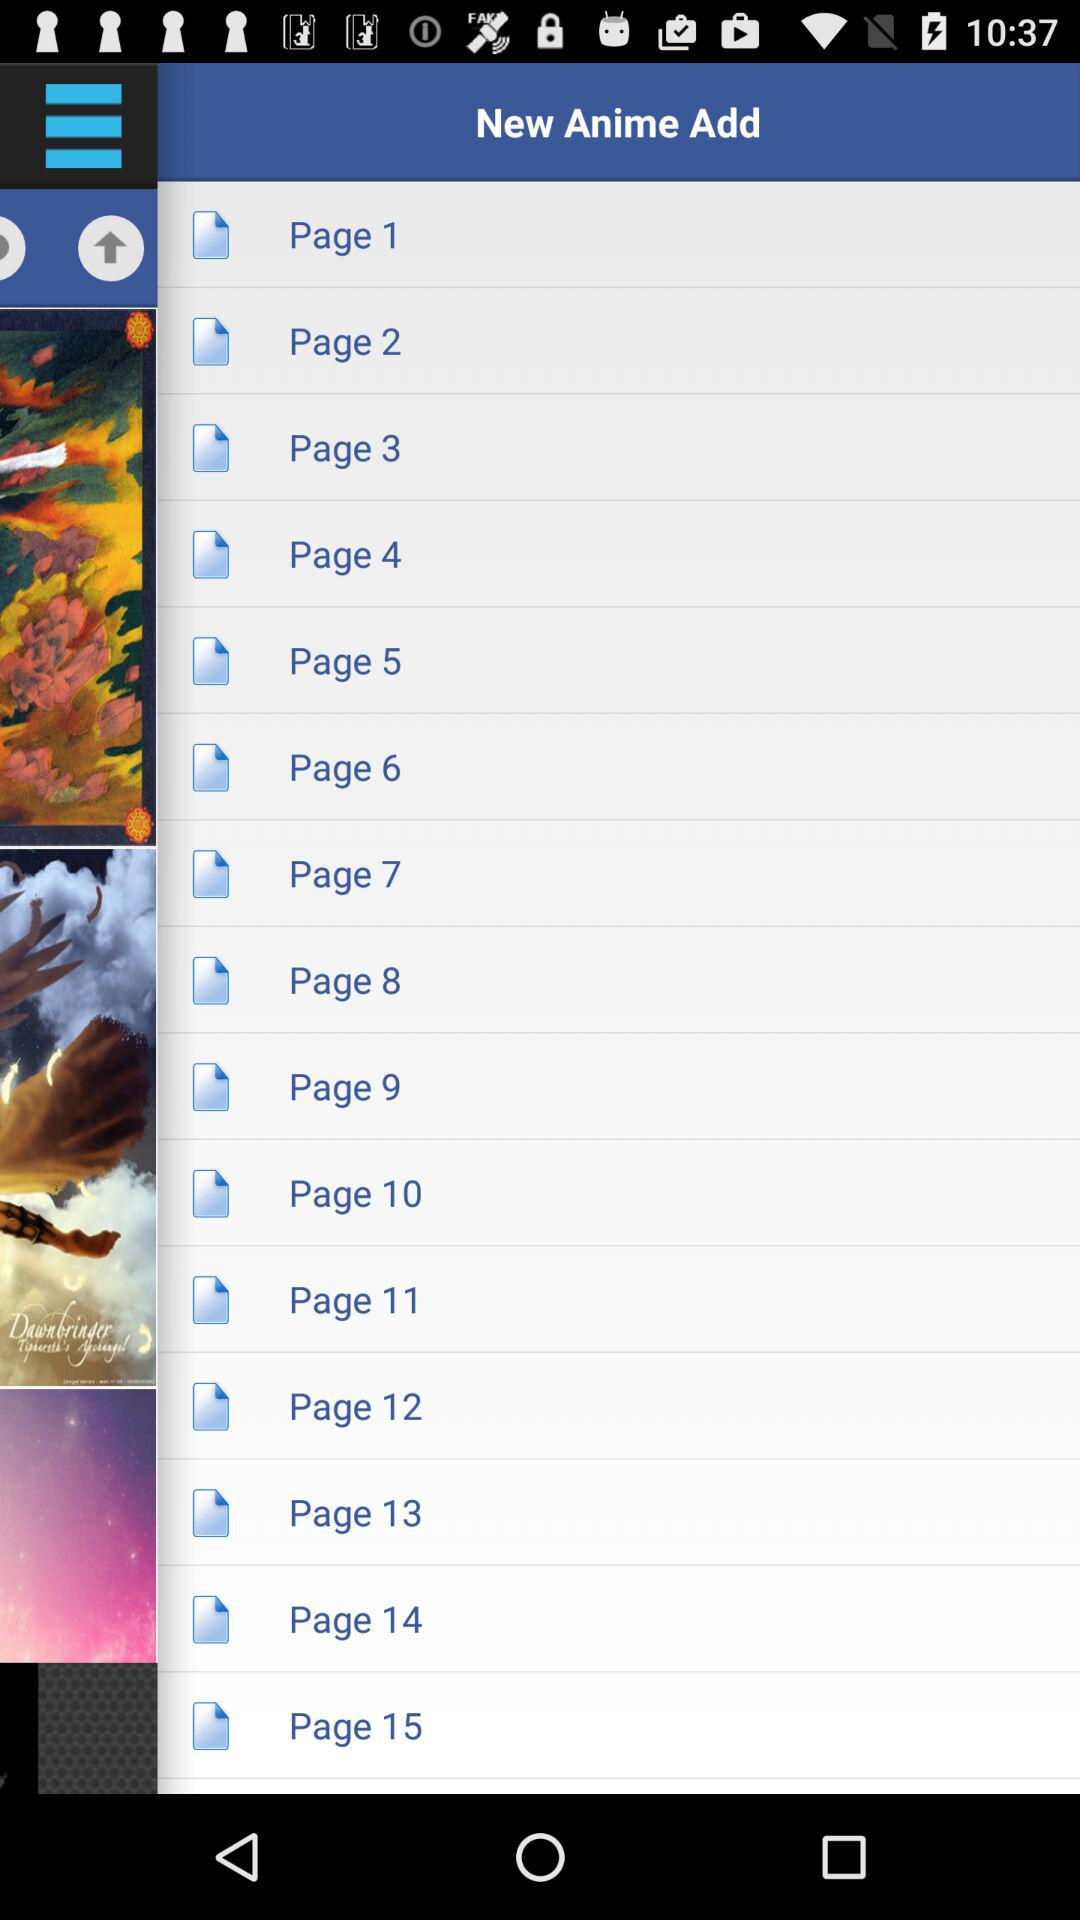How many more pages are there after page 10?
Answer the question using a single word or phrase. 5 